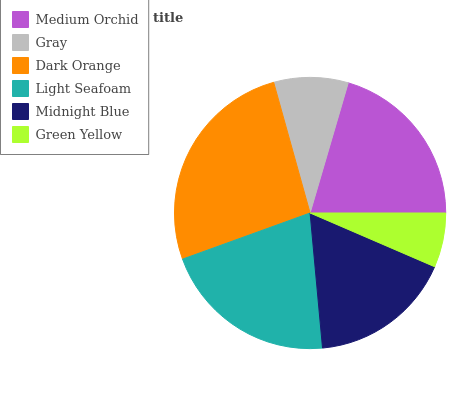Is Green Yellow the minimum?
Answer yes or no. Yes. Is Dark Orange the maximum?
Answer yes or no. Yes. Is Gray the minimum?
Answer yes or no. No. Is Gray the maximum?
Answer yes or no. No. Is Medium Orchid greater than Gray?
Answer yes or no. Yes. Is Gray less than Medium Orchid?
Answer yes or no. Yes. Is Gray greater than Medium Orchid?
Answer yes or no. No. Is Medium Orchid less than Gray?
Answer yes or no. No. Is Medium Orchid the high median?
Answer yes or no. Yes. Is Midnight Blue the low median?
Answer yes or no. Yes. Is Midnight Blue the high median?
Answer yes or no. No. Is Light Seafoam the low median?
Answer yes or no. No. 